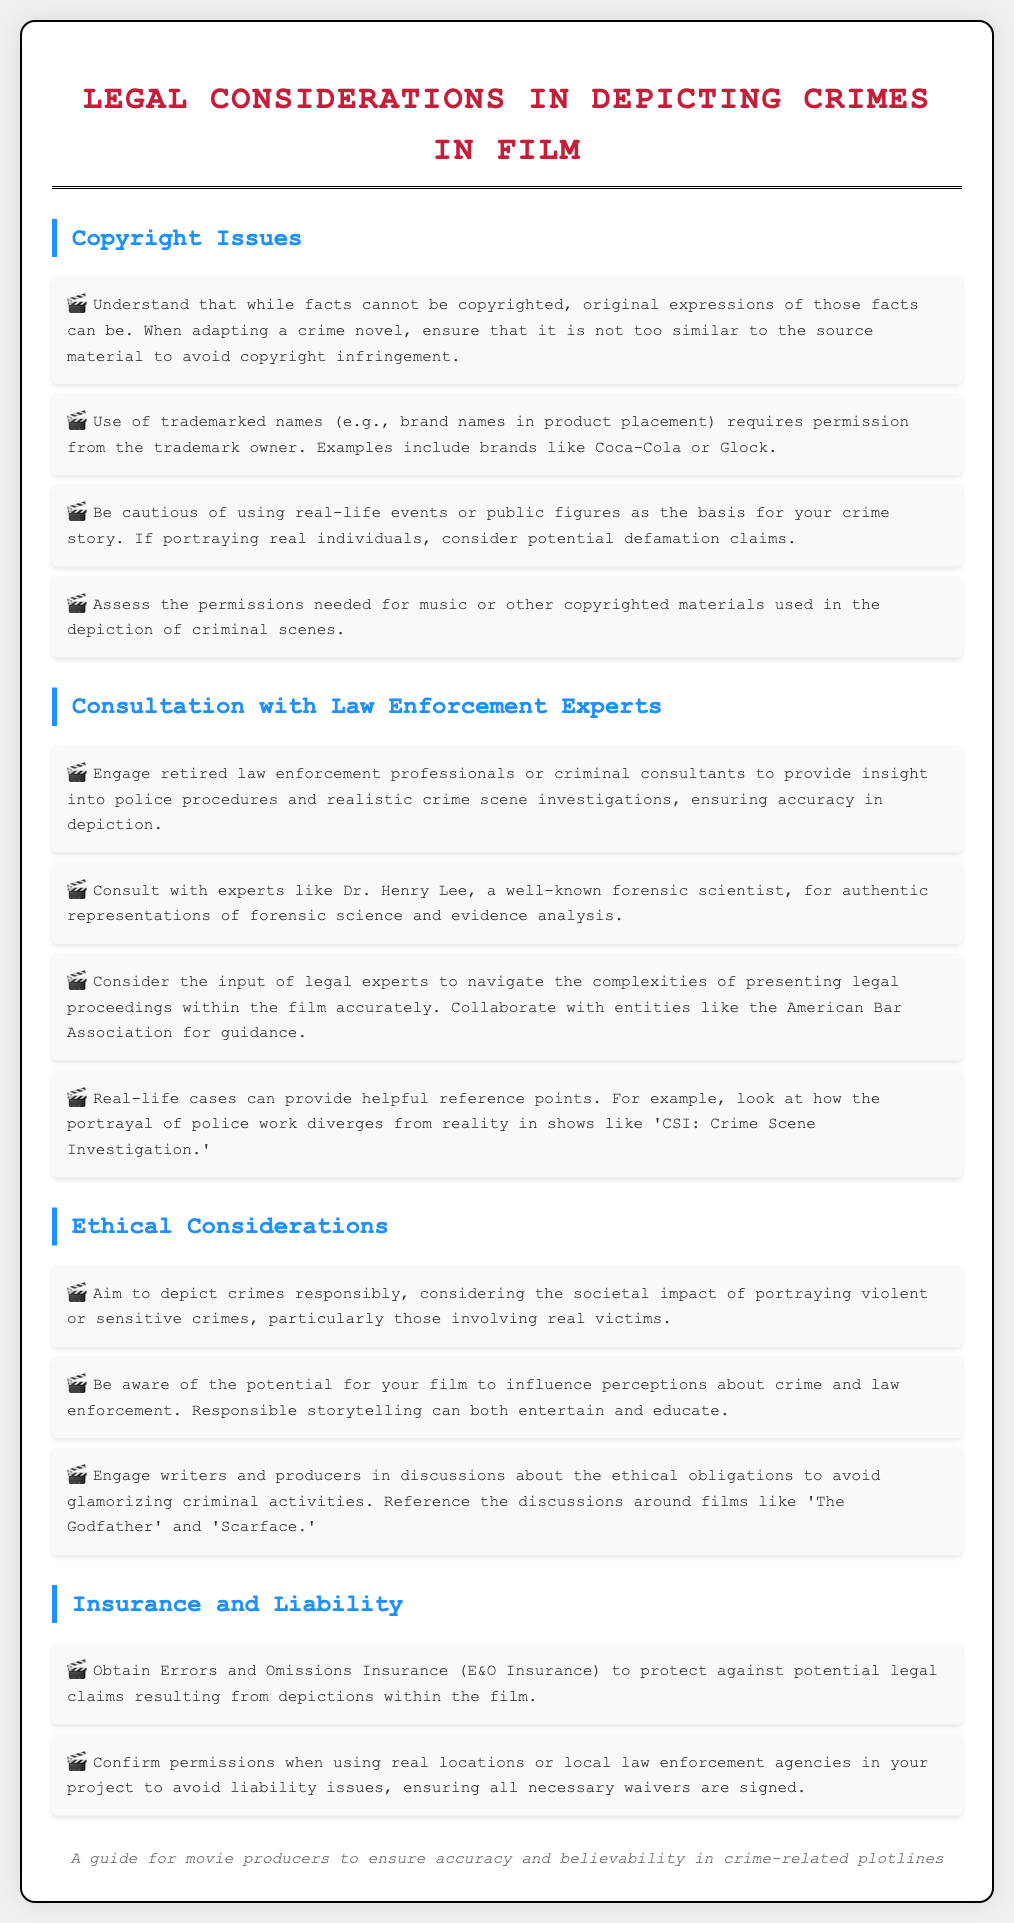What are the legal considerations in depicting crimes in film? The document outlines various legal considerations, including copyright issues, consultation with law enforcement experts, ethical considerations, and insurance and liability.
Answer: Copyright issues, consultation with law enforcement experts, ethical considerations, insurance and liability Who should be consulted for forensic science expertise? The document mentions Dr. Henry Lee as a well-known forensic scientist to consult for authentic representations of forensic science and evidence analysis.
Answer: Dr. Henry Lee What insurance is recommended for legal protection? Errors and Omissions Insurance (E&O Insurance) is recommended to protect against potential legal claims resulting from depictions within the film.
Answer: E&O Insurance What is a potential consequence of depicting real-life events or public figures? Portraying real individuals can lead to potential defamation claims as noted in the document.
Answer: Defamation claims How should violent or sensitive crimes be depicted? The document suggests aiming to depict crimes responsibly, considering their societal impact.
Answer: Responsibly What group can provide guidance on legal proceedings in film? The American Bar Association is mentioned as an entity that can provide guidance on legal proceedings presented in films.
Answer: American Bar Association 